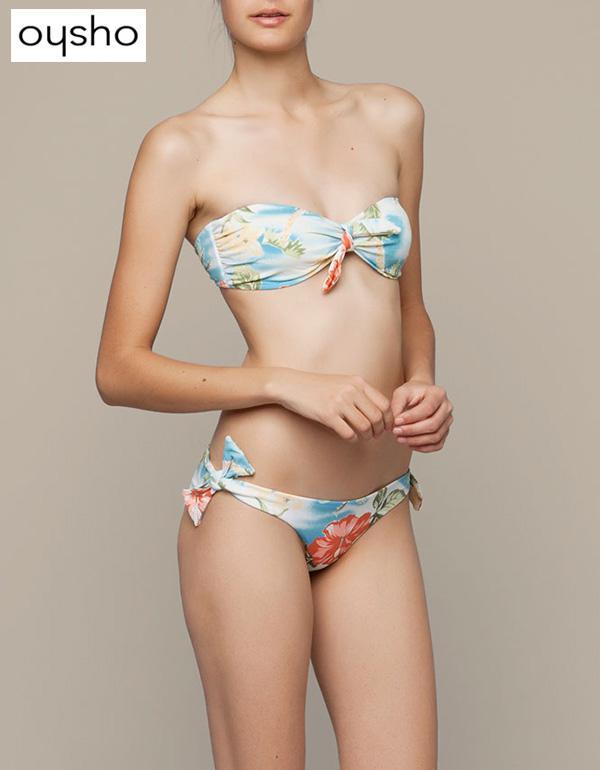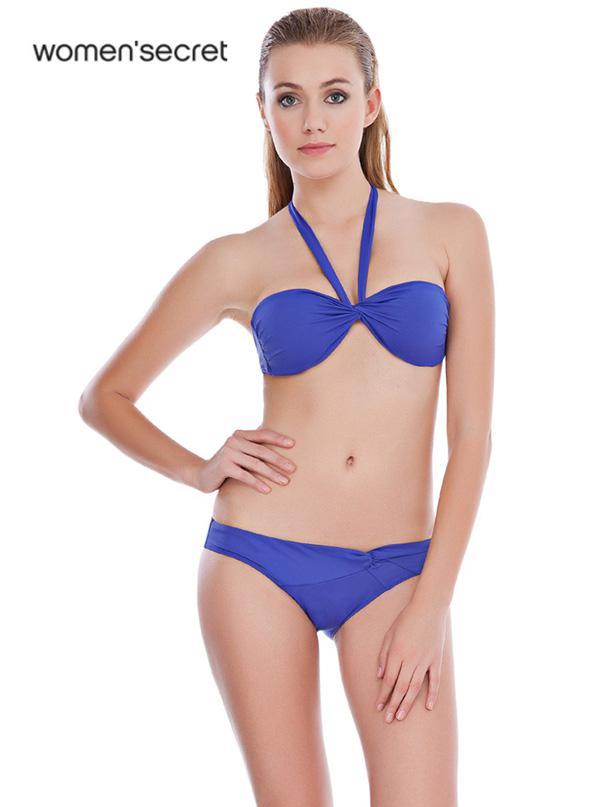The first image is the image on the left, the second image is the image on the right. For the images shown, is this caption "One image shows a girl in a bikini with straps and solid color, standing with one hand on her upper hip." true? Answer yes or no. Yes. The first image is the image on the left, the second image is the image on the right. Given the left and right images, does the statement "A woman is touching her hair." hold true? Answer yes or no. No. 